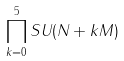<formula> <loc_0><loc_0><loc_500><loc_500>\prod _ { k = 0 } ^ { 5 } S U ( N + k M )</formula> 